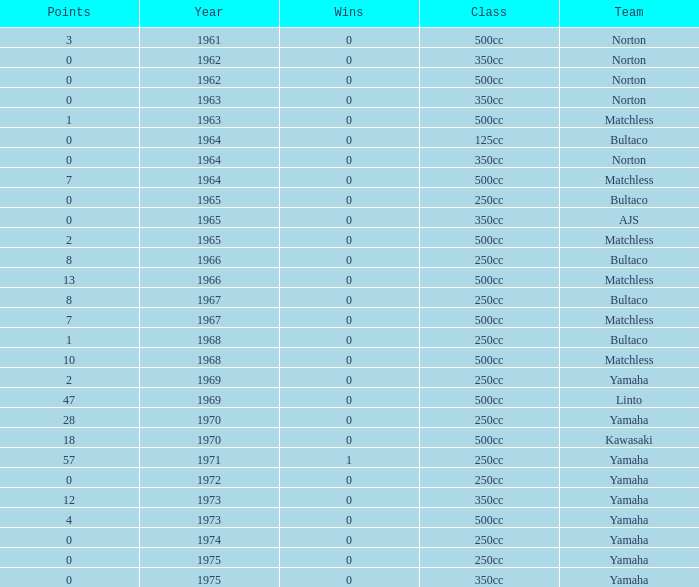What is the average wins in 250cc class for Bultaco with 8 points later than 1966? 0.0. 